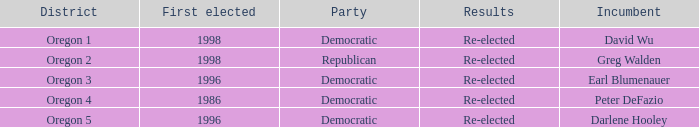What was the result of the Oregon 5 District incumbent who was first elected in 1996? Re-elected. 